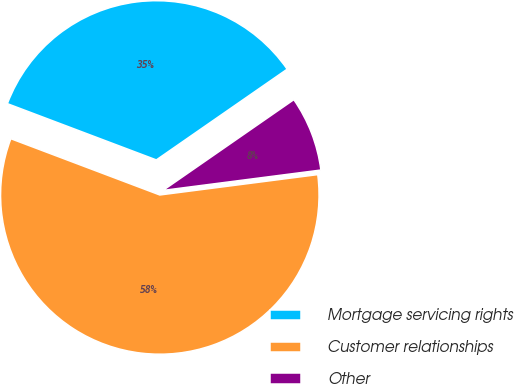Convert chart to OTSL. <chart><loc_0><loc_0><loc_500><loc_500><pie_chart><fcel>Mortgage servicing rights<fcel>Customer relationships<fcel>Other<nl><fcel>34.6%<fcel>57.79%<fcel>7.61%<nl></chart> 